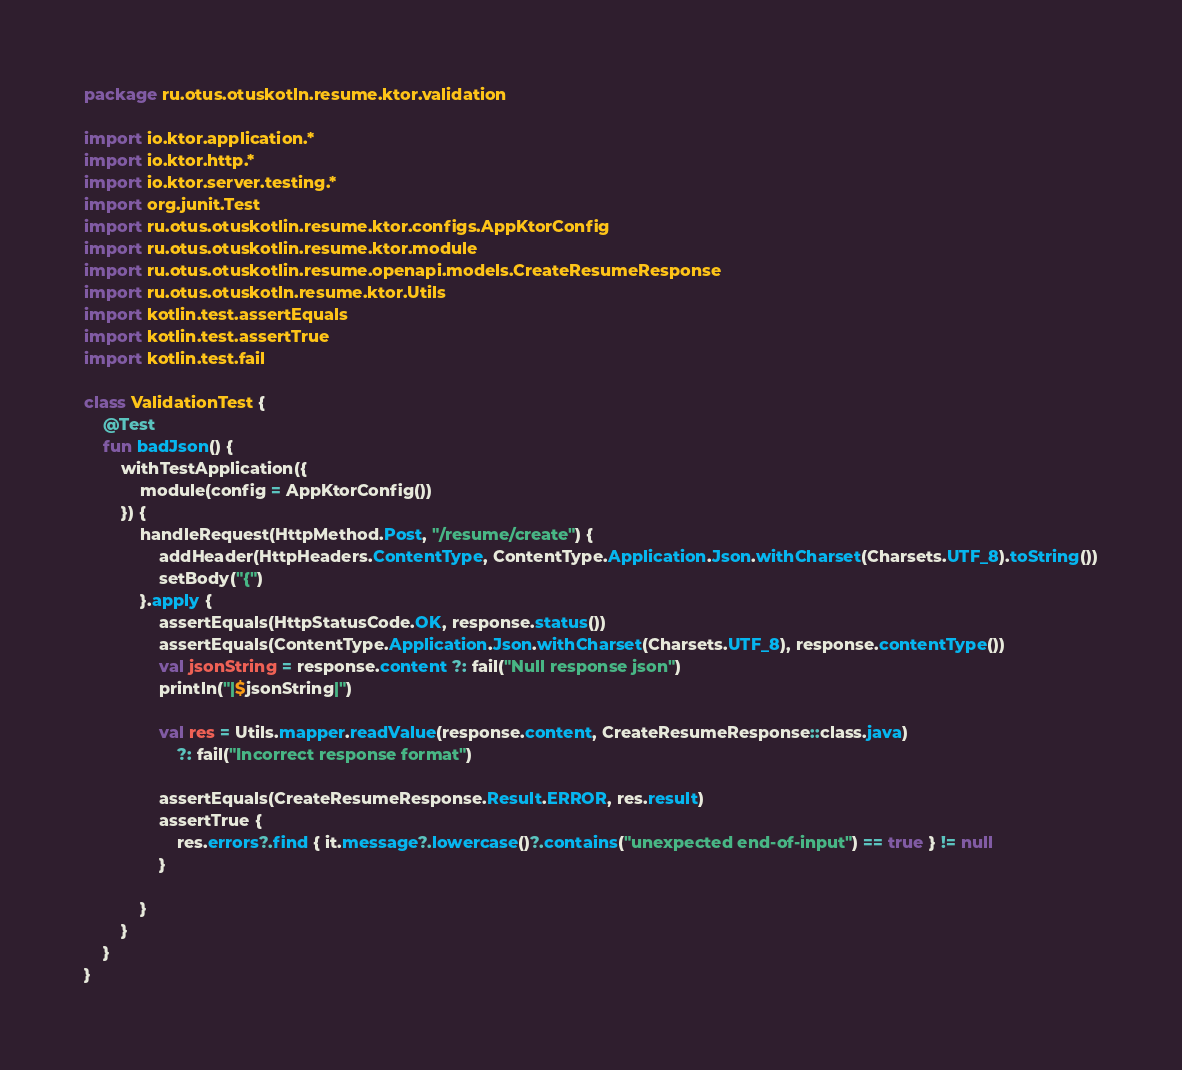Convert code to text. <code><loc_0><loc_0><loc_500><loc_500><_Kotlin_>package ru.otus.otuskotln.resume.ktor.validation

import io.ktor.application.*
import io.ktor.http.*
import io.ktor.server.testing.*
import org.junit.Test
import ru.otus.otuskotlin.resume.ktor.configs.AppKtorConfig
import ru.otus.otuskotlin.resume.ktor.module
import ru.otus.otuskotlin.resume.openapi.models.CreateResumeResponse
import ru.otus.otuskotln.resume.ktor.Utils
import kotlin.test.assertEquals
import kotlin.test.assertTrue
import kotlin.test.fail

class ValidationTest {
    @Test
    fun badJson() {
        withTestApplication({
            module(config = AppKtorConfig())
        }) {
            handleRequest(HttpMethod.Post, "/resume/create") {
                addHeader(HttpHeaders.ContentType, ContentType.Application.Json.withCharset(Charsets.UTF_8).toString())
                setBody("{")
            }.apply {
                assertEquals(HttpStatusCode.OK, response.status())
                assertEquals(ContentType.Application.Json.withCharset(Charsets.UTF_8), response.contentType())
                val jsonString = response.content ?: fail("Null response json")
                println("|$jsonString|")

                val res = Utils.mapper.readValue(response.content, CreateResumeResponse::class.java)
                    ?: fail("Incorrect response format")

                assertEquals(CreateResumeResponse.Result.ERROR, res.result)
                assertTrue {
                    res.errors?.find { it.message?.lowercase()?.contains("unexpected end-of-input") == true } != null
                }

            }
        }
    }
}</code> 